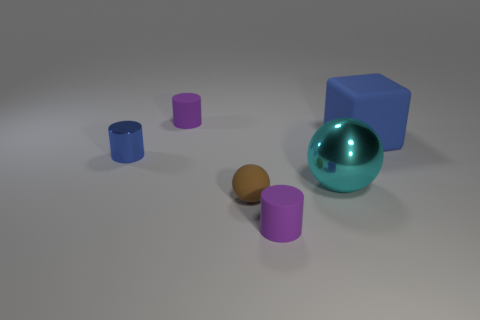The rubber ball is what size? The rubber ball appears to be of a small size, comparable to the smaller geometric shapes surrounding it, but slightly larger than the smallest cylinder. 